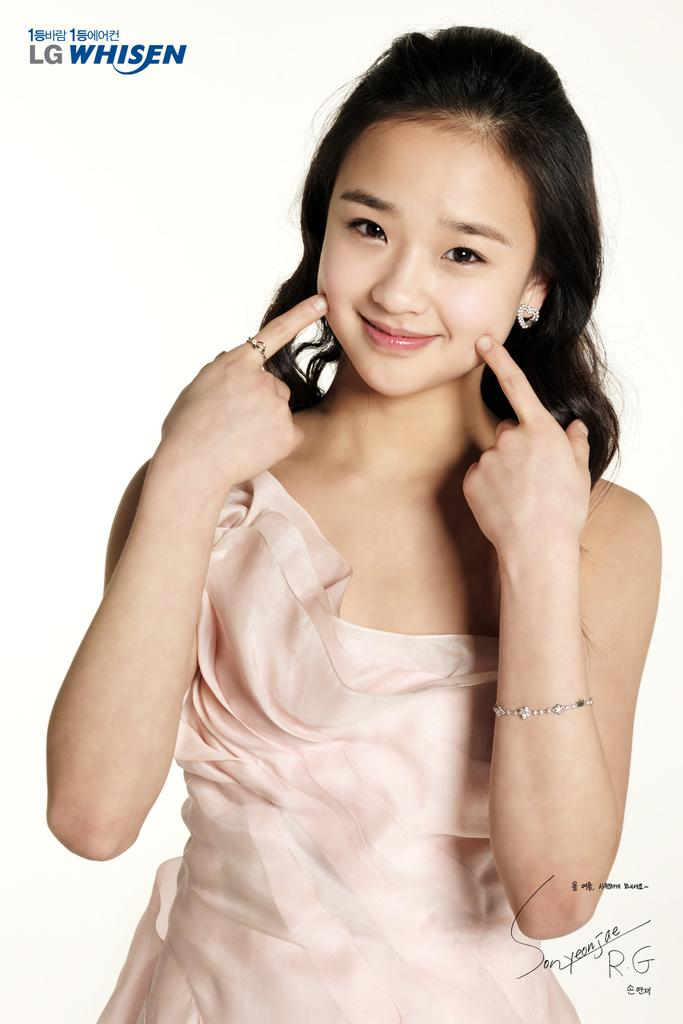Who is the main subject in the image? There is a woman in the image. What is written at the top of the image? There is text at the top of the image. What can be found at the bottom of the image? There is a signature at the bottom of the image. What is the color of the background in the image? The background of the image is white. What hobbies does the woman in the image enjoy during her vacation with the organization? There is no information about the woman's hobbies, vacation, or any organization in the image. 